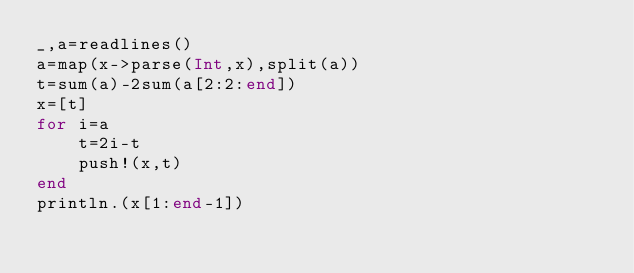Convert code to text. <code><loc_0><loc_0><loc_500><loc_500><_Julia_>_,a=readlines()
a=map(x->parse(Int,x),split(a))
t=sum(a)-2sum(a[2:2:end])
x=[t]
for i=a
    t=2i-t
    push!(x,t)
end
println.(x[1:end-1])</code> 